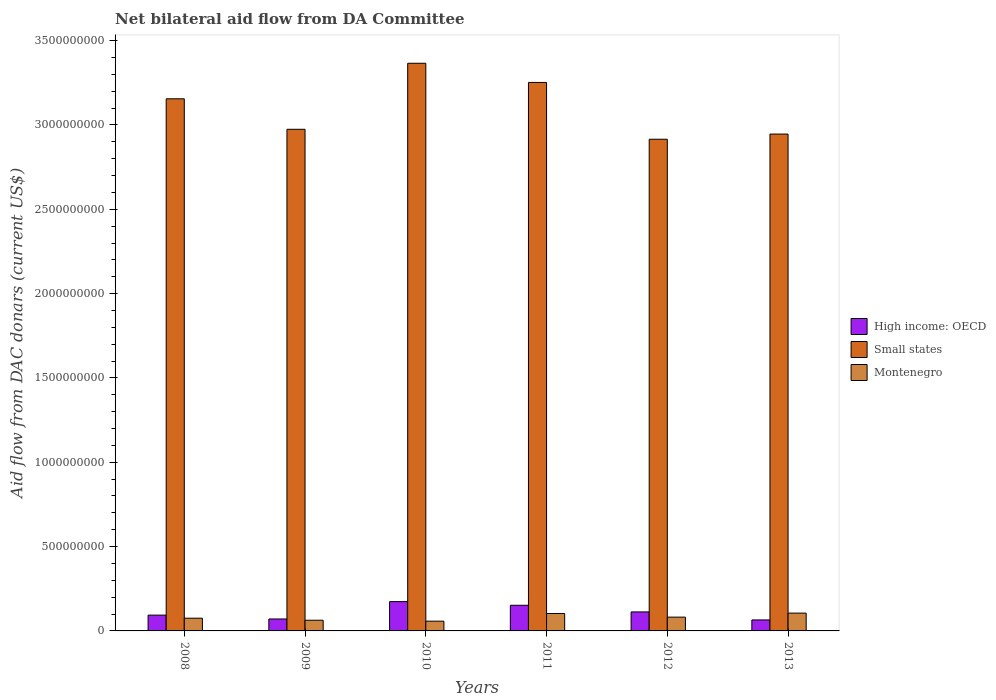How many groups of bars are there?
Give a very brief answer. 6. Are the number of bars per tick equal to the number of legend labels?
Offer a very short reply. Yes. Are the number of bars on each tick of the X-axis equal?
Keep it short and to the point. Yes. What is the label of the 6th group of bars from the left?
Provide a short and direct response. 2013. What is the aid flow in in High income: OECD in 2008?
Provide a succinct answer. 9.37e+07. Across all years, what is the maximum aid flow in in High income: OECD?
Ensure brevity in your answer.  1.74e+08. Across all years, what is the minimum aid flow in in Small states?
Your answer should be very brief. 2.92e+09. In which year was the aid flow in in Montenegro maximum?
Offer a terse response. 2013. In which year was the aid flow in in High income: OECD minimum?
Offer a terse response. 2013. What is the total aid flow in in Small states in the graph?
Your response must be concise. 1.86e+1. What is the difference between the aid flow in in High income: OECD in 2010 and that in 2013?
Give a very brief answer. 1.09e+08. What is the difference between the aid flow in in High income: OECD in 2010 and the aid flow in in Montenegro in 2012?
Offer a very short reply. 9.20e+07. What is the average aid flow in in Montenegro per year?
Your response must be concise. 8.12e+07. In the year 2012, what is the difference between the aid flow in in Small states and aid flow in in Montenegro?
Your response must be concise. 2.83e+09. What is the ratio of the aid flow in in Small states in 2009 to that in 2013?
Provide a succinct answer. 1.01. Is the aid flow in in Small states in 2012 less than that in 2013?
Your answer should be compact. Yes. What is the difference between the highest and the second highest aid flow in in Montenegro?
Offer a very short reply. 2.31e+06. What is the difference between the highest and the lowest aid flow in in Montenegro?
Ensure brevity in your answer.  4.77e+07. In how many years, is the aid flow in in Montenegro greater than the average aid flow in in Montenegro taken over all years?
Your response must be concise. 3. Is the sum of the aid flow in in Small states in 2009 and 2010 greater than the maximum aid flow in in High income: OECD across all years?
Give a very brief answer. Yes. What does the 1st bar from the left in 2009 represents?
Give a very brief answer. High income: OECD. What does the 1st bar from the right in 2012 represents?
Ensure brevity in your answer.  Montenegro. Is it the case that in every year, the sum of the aid flow in in Montenegro and aid flow in in High income: OECD is greater than the aid flow in in Small states?
Make the answer very short. No. Are all the bars in the graph horizontal?
Offer a terse response. No. Are the values on the major ticks of Y-axis written in scientific E-notation?
Make the answer very short. No. Does the graph contain any zero values?
Offer a very short reply. No. How many legend labels are there?
Ensure brevity in your answer.  3. What is the title of the graph?
Offer a very short reply. Net bilateral aid flow from DA Committee. What is the label or title of the X-axis?
Offer a terse response. Years. What is the label or title of the Y-axis?
Offer a terse response. Aid flow from DAC donars (current US$). What is the Aid flow from DAC donars (current US$) of High income: OECD in 2008?
Your response must be concise. 9.37e+07. What is the Aid flow from DAC donars (current US$) of Small states in 2008?
Make the answer very short. 3.16e+09. What is the Aid flow from DAC donars (current US$) of Montenegro in 2008?
Provide a short and direct response. 7.55e+07. What is the Aid flow from DAC donars (current US$) of High income: OECD in 2009?
Provide a short and direct response. 7.08e+07. What is the Aid flow from DAC donars (current US$) in Small states in 2009?
Offer a terse response. 2.97e+09. What is the Aid flow from DAC donars (current US$) in Montenegro in 2009?
Give a very brief answer. 6.33e+07. What is the Aid flow from DAC donars (current US$) of High income: OECD in 2010?
Your answer should be compact. 1.74e+08. What is the Aid flow from DAC donars (current US$) of Small states in 2010?
Make the answer very short. 3.37e+09. What is the Aid flow from DAC donars (current US$) in Montenegro in 2010?
Your answer should be very brief. 5.79e+07. What is the Aid flow from DAC donars (current US$) of High income: OECD in 2011?
Ensure brevity in your answer.  1.52e+08. What is the Aid flow from DAC donars (current US$) in Small states in 2011?
Offer a terse response. 3.25e+09. What is the Aid flow from DAC donars (current US$) in Montenegro in 2011?
Ensure brevity in your answer.  1.03e+08. What is the Aid flow from DAC donars (current US$) of High income: OECD in 2012?
Your answer should be compact. 1.13e+08. What is the Aid flow from DAC donars (current US$) of Small states in 2012?
Your response must be concise. 2.92e+09. What is the Aid flow from DAC donars (current US$) of Montenegro in 2012?
Provide a succinct answer. 8.17e+07. What is the Aid flow from DAC donars (current US$) of High income: OECD in 2013?
Offer a terse response. 6.52e+07. What is the Aid flow from DAC donars (current US$) of Small states in 2013?
Your answer should be compact. 2.95e+09. What is the Aid flow from DAC donars (current US$) in Montenegro in 2013?
Your answer should be very brief. 1.06e+08. Across all years, what is the maximum Aid flow from DAC donars (current US$) in High income: OECD?
Provide a short and direct response. 1.74e+08. Across all years, what is the maximum Aid flow from DAC donars (current US$) in Small states?
Provide a short and direct response. 3.37e+09. Across all years, what is the maximum Aid flow from DAC donars (current US$) of Montenegro?
Provide a short and direct response. 1.06e+08. Across all years, what is the minimum Aid flow from DAC donars (current US$) of High income: OECD?
Provide a succinct answer. 6.52e+07. Across all years, what is the minimum Aid flow from DAC donars (current US$) in Small states?
Your answer should be very brief. 2.92e+09. Across all years, what is the minimum Aid flow from DAC donars (current US$) of Montenegro?
Your response must be concise. 5.79e+07. What is the total Aid flow from DAC donars (current US$) of High income: OECD in the graph?
Make the answer very short. 6.68e+08. What is the total Aid flow from DAC donars (current US$) of Small states in the graph?
Provide a succinct answer. 1.86e+1. What is the total Aid flow from DAC donars (current US$) of Montenegro in the graph?
Offer a terse response. 4.87e+08. What is the difference between the Aid flow from DAC donars (current US$) of High income: OECD in 2008 and that in 2009?
Make the answer very short. 2.29e+07. What is the difference between the Aid flow from DAC donars (current US$) in Small states in 2008 and that in 2009?
Offer a terse response. 1.81e+08. What is the difference between the Aid flow from DAC donars (current US$) of Montenegro in 2008 and that in 2009?
Provide a succinct answer. 1.22e+07. What is the difference between the Aid flow from DAC donars (current US$) in High income: OECD in 2008 and that in 2010?
Your response must be concise. -8.01e+07. What is the difference between the Aid flow from DAC donars (current US$) of Small states in 2008 and that in 2010?
Your answer should be very brief. -2.11e+08. What is the difference between the Aid flow from DAC donars (current US$) of Montenegro in 2008 and that in 2010?
Make the answer very short. 1.76e+07. What is the difference between the Aid flow from DAC donars (current US$) in High income: OECD in 2008 and that in 2011?
Make the answer very short. -5.84e+07. What is the difference between the Aid flow from DAC donars (current US$) in Small states in 2008 and that in 2011?
Provide a succinct answer. -9.70e+07. What is the difference between the Aid flow from DAC donars (current US$) in Montenegro in 2008 and that in 2011?
Your answer should be compact. -2.78e+07. What is the difference between the Aid flow from DAC donars (current US$) in High income: OECD in 2008 and that in 2012?
Give a very brief answer. -1.90e+07. What is the difference between the Aid flow from DAC donars (current US$) of Small states in 2008 and that in 2012?
Offer a very short reply. 2.40e+08. What is the difference between the Aid flow from DAC donars (current US$) of Montenegro in 2008 and that in 2012?
Make the answer very short. -6.24e+06. What is the difference between the Aid flow from DAC donars (current US$) in High income: OECD in 2008 and that in 2013?
Offer a very short reply. 2.85e+07. What is the difference between the Aid flow from DAC donars (current US$) in Small states in 2008 and that in 2013?
Give a very brief answer. 2.09e+08. What is the difference between the Aid flow from DAC donars (current US$) in Montenegro in 2008 and that in 2013?
Your answer should be compact. -3.01e+07. What is the difference between the Aid flow from DAC donars (current US$) in High income: OECD in 2009 and that in 2010?
Keep it short and to the point. -1.03e+08. What is the difference between the Aid flow from DAC donars (current US$) of Small states in 2009 and that in 2010?
Make the answer very short. -3.91e+08. What is the difference between the Aid flow from DAC donars (current US$) in Montenegro in 2009 and that in 2010?
Ensure brevity in your answer.  5.44e+06. What is the difference between the Aid flow from DAC donars (current US$) of High income: OECD in 2009 and that in 2011?
Ensure brevity in your answer.  -8.13e+07. What is the difference between the Aid flow from DAC donars (current US$) in Small states in 2009 and that in 2011?
Your response must be concise. -2.78e+08. What is the difference between the Aid flow from DAC donars (current US$) in Montenegro in 2009 and that in 2011?
Your answer should be compact. -4.00e+07. What is the difference between the Aid flow from DAC donars (current US$) in High income: OECD in 2009 and that in 2012?
Your answer should be very brief. -4.19e+07. What is the difference between the Aid flow from DAC donars (current US$) in Small states in 2009 and that in 2012?
Ensure brevity in your answer.  5.91e+07. What is the difference between the Aid flow from DAC donars (current US$) in Montenegro in 2009 and that in 2012?
Offer a terse response. -1.84e+07. What is the difference between the Aid flow from DAC donars (current US$) of High income: OECD in 2009 and that in 2013?
Offer a terse response. 5.59e+06. What is the difference between the Aid flow from DAC donars (current US$) of Small states in 2009 and that in 2013?
Your response must be concise. 2.84e+07. What is the difference between the Aid flow from DAC donars (current US$) in Montenegro in 2009 and that in 2013?
Offer a very short reply. -4.23e+07. What is the difference between the Aid flow from DAC donars (current US$) in High income: OECD in 2010 and that in 2011?
Give a very brief answer. 2.17e+07. What is the difference between the Aid flow from DAC donars (current US$) of Small states in 2010 and that in 2011?
Your response must be concise. 1.14e+08. What is the difference between the Aid flow from DAC donars (current US$) in Montenegro in 2010 and that in 2011?
Your answer should be compact. -4.54e+07. What is the difference between the Aid flow from DAC donars (current US$) in High income: OECD in 2010 and that in 2012?
Your response must be concise. 6.11e+07. What is the difference between the Aid flow from DAC donars (current US$) of Small states in 2010 and that in 2012?
Provide a short and direct response. 4.51e+08. What is the difference between the Aid flow from DAC donars (current US$) in Montenegro in 2010 and that in 2012?
Offer a terse response. -2.39e+07. What is the difference between the Aid flow from DAC donars (current US$) of High income: OECD in 2010 and that in 2013?
Offer a very short reply. 1.09e+08. What is the difference between the Aid flow from DAC donars (current US$) of Small states in 2010 and that in 2013?
Provide a short and direct response. 4.20e+08. What is the difference between the Aid flow from DAC donars (current US$) of Montenegro in 2010 and that in 2013?
Offer a terse response. -4.77e+07. What is the difference between the Aid flow from DAC donars (current US$) of High income: OECD in 2011 and that in 2012?
Offer a terse response. 3.94e+07. What is the difference between the Aid flow from DAC donars (current US$) in Small states in 2011 and that in 2012?
Give a very brief answer. 3.37e+08. What is the difference between the Aid flow from DAC donars (current US$) in Montenegro in 2011 and that in 2012?
Keep it short and to the point. 2.16e+07. What is the difference between the Aid flow from DAC donars (current US$) in High income: OECD in 2011 and that in 2013?
Give a very brief answer. 8.68e+07. What is the difference between the Aid flow from DAC donars (current US$) in Small states in 2011 and that in 2013?
Ensure brevity in your answer.  3.06e+08. What is the difference between the Aid flow from DAC donars (current US$) in Montenegro in 2011 and that in 2013?
Give a very brief answer. -2.31e+06. What is the difference between the Aid flow from DAC donars (current US$) of High income: OECD in 2012 and that in 2013?
Give a very brief answer. 4.75e+07. What is the difference between the Aid flow from DAC donars (current US$) in Small states in 2012 and that in 2013?
Your answer should be very brief. -3.07e+07. What is the difference between the Aid flow from DAC donars (current US$) in Montenegro in 2012 and that in 2013?
Make the answer very short. -2.39e+07. What is the difference between the Aid flow from DAC donars (current US$) of High income: OECD in 2008 and the Aid flow from DAC donars (current US$) of Small states in 2009?
Your answer should be compact. -2.88e+09. What is the difference between the Aid flow from DAC donars (current US$) of High income: OECD in 2008 and the Aid flow from DAC donars (current US$) of Montenegro in 2009?
Provide a succinct answer. 3.04e+07. What is the difference between the Aid flow from DAC donars (current US$) in Small states in 2008 and the Aid flow from DAC donars (current US$) in Montenegro in 2009?
Provide a succinct answer. 3.09e+09. What is the difference between the Aid flow from DAC donars (current US$) in High income: OECD in 2008 and the Aid flow from DAC donars (current US$) in Small states in 2010?
Your answer should be very brief. -3.27e+09. What is the difference between the Aid flow from DAC donars (current US$) of High income: OECD in 2008 and the Aid flow from DAC donars (current US$) of Montenegro in 2010?
Offer a terse response. 3.58e+07. What is the difference between the Aid flow from DAC donars (current US$) of Small states in 2008 and the Aid flow from DAC donars (current US$) of Montenegro in 2010?
Your answer should be very brief. 3.10e+09. What is the difference between the Aid flow from DAC donars (current US$) in High income: OECD in 2008 and the Aid flow from DAC donars (current US$) in Small states in 2011?
Give a very brief answer. -3.16e+09. What is the difference between the Aid flow from DAC donars (current US$) of High income: OECD in 2008 and the Aid flow from DAC donars (current US$) of Montenegro in 2011?
Offer a terse response. -9.62e+06. What is the difference between the Aid flow from DAC donars (current US$) of Small states in 2008 and the Aid flow from DAC donars (current US$) of Montenegro in 2011?
Make the answer very short. 3.05e+09. What is the difference between the Aid flow from DAC donars (current US$) of High income: OECD in 2008 and the Aid flow from DAC donars (current US$) of Small states in 2012?
Offer a terse response. -2.82e+09. What is the difference between the Aid flow from DAC donars (current US$) in High income: OECD in 2008 and the Aid flow from DAC donars (current US$) in Montenegro in 2012?
Make the answer very short. 1.20e+07. What is the difference between the Aid flow from DAC donars (current US$) of Small states in 2008 and the Aid flow from DAC donars (current US$) of Montenegro in 2012?
Keep it short and to the point. 3.07e+09. What is the difference between the Aid flow from DAC donars (current US$) of High income: OECD in 2008 and the Aid flow from DAC donars (current US$) of Small states in 2013?
Ensure brevity in your answer.  -2.85e+09. What is the difference between the Aid flow from DAC donars (current US$) in High income: OECD in 2008 and the Aid flow from DAC donars (current US$) in Montenegro in 2013?
Give a very brief answer. -1.19e+07. What is the difference between the Aid flow from DAC donars (current US$) of Small states in 2008 and the Aid flow from DAC donars (current US$) of Montenegro in 2013?
Give a very brief answer. 3.05e+09. What is the difference between the Aid flow from DAC donars (current US$) in High income: OECD in 2009 and the Aid flow from DAC donars (current US$) in Small states in 2010?
Give a very brief answer. -3.30e+09. What is the difference between the Aid flow from DAC donars (current US$) in High income: OECD in 2009 and the Aid flow from DAC donars (current US$) in Montenegro in 2010?
Provide a succinct answer. 1.29e+07. What is the difference between the Aid flow from DAC donars (current US$) of Small states in 2009 and the Aid flow from DAC donars (current US$) of Montenegro in 2010?
Offer a terse response. 2.92e+09. What is the difference between the Aid flow from DAC donars (current US$) in High income: OECD in 2009 and the Aid flow from DAC donars (current US$) in Small states in 2011?
Offer a terse response. -3.18e+09. What is the difference between the Aid flow from DAC donars (current US$) in High income: OECD in 2009 and the Aid flow from DAC donars (current US$) in Montenegro in 2011?
Your response must be concise. -3.25e+07. What is the difference between the Aid flow from DAC donars (current US$) in Small states in 2009 and the Aid flow from DAC donars (current US$) in Montenegro in 2011?
Provide a short and direct response. 2.87e+09. What is the difference between the Aid flow from DAC donars (current US$) in High income: OECD in 2009 and the Aid flow from DAC donars (current US$) in Small states in 2012?
Make the answer very short. -2.84e+09. What is the difference between the Aid flow from DAC donars (current US$) in High income: OECD in 2009 and the Aid flow from DAC donars (current US$) in Montenegro in 2012?
Your answer should be compact. -1.09e+07. What is the difference between the Aid flow from DAC donars (current US$) of Small states in 2009 and the Aid flow from DAC donars (current US$) of Montenegro in 2012?
Make the answer very short. 2.89e+09. What is the difference between the Aid flow from DAC donars (current US$) of High income: OECD in 2009 and the Aid flow from DAC donars (current US$) of Small states in 2013?
Your answer should be compact. -2.88e+09. What is the difference between the Aid flow from DAC donars (current US$) in High income: OECD in 2009 and the Aid flow from DAC donars (current US$) in Montenegro in 2013?
Your answer should be compact. -3.48e+07. What is the difference between the Aid flow from DAC donars (current US$) of Small states in 2009 and the Aid flow from DAC donars (current US$) of Montenegro in 2013?
Provide a succinct answer. 2.87e+09. What is the difference between the Aid flow from DAC donars (current US$) of High income: OECD in 2010 and the Aid flow from DAC donars (current US$) of Small states in 2011?
Keep it short and to the point. -3.08e+09. What is the difference between the Aid flow from DAC donars (current US$) of High income: OECD in 2010 and the Aid flow from DAC donars (current US$) of Montenegro in 2011?
Offer a very short reply. 7.04e+07. What is the difference between the Aid flow from DAC donars (current US$) of Small states in 2010 and the Aid flow from DAC donars (current US$) of Montenegro in 2011?
Offer a very short reply. 3.26e+09. What is the difference between the Aid flow from DAC donars (current US$) of High income: OECD in 2010 and the Aid flow from DAC donars (current US$) of Small states in 2012?
Your response must be concise. -2.74e+09. What is the difference between the Aid flow from DAC donars (current US$) in High income: OECD in 2010 and the Aid flow from DAC donars (current US$) in Montenegro in 2012?
Your answer should be compact. 9.20e+07. What is the difference between the Aid flow from DAC donars (current US$) in Small states in 2010 and the Aid flow from DAC donars (current US$) in Montenegro in 2012?
Ensure brevity in your answer.  3.28e+09. What is the difference between the Aid flow from DAC donars (current US$) in High income: OECD in 2010 and the Aid flow from DAC donars (current US$) in Small states in 2013?
Offer a very short reply. -2.77e+09. What is the difference between the Aid flow from DAC donars (current US$) of High income: OECD in 2010 and the Aid flow from DAC donars (current US$) of Montenegro in 2013?
Provide a succinct answer. 6.81e+07. What is the difference between the Aid flow from DAC donars (current US$) of Small states in 2010 and the Aid flow from DAC donars (current US$) of Montenegro in 2013?
Your answer should be compact. 3.26e+09. What is the difference between the Aid flow from DAC donars (current US$) in High income: OECD in 2011 and the Aid flow from DAC donars (current US$) in Small states in 2012?
Provide a succinct answer. -2.76e+09. What is the difference between the Aid flow from DAC donars (current US$) in High income: OECD in 2011 and the Aid flow from DAC donars (current US$) in Montenegro in 2012?
Ensure brevity in your answer.  7.03e+07. What is the difference between the Aid flow from DAC donars (current US$) in Small states in 2011 and the Aid flow from DAC donars (current US$) in Montenegro in 2012?
Provide a short and direct response. 3.17e+09. What is the difference between the Aid flow from DAC donars (current US$) of High income: OECD in 2011 and the Aid flow from DAC donars (current US$) of Small states in 2013?
Offer a terse response. -2.79e+09. What is the difference between the Aid flow from DAC donars (current US$) in High income: OECD in 2011 and the Aid flow from DAC donars (current US$) in Montenegro in 2013?
Ensure brevity in your answer.  4.64e+07. What is the difference between the Aid flow from DAC donars (current US$) of Small states in 2011 and the Aid flow from DAC donars (current US$) of Montenegro in 2013?
Offer a very short reply. 3.15e+09. What is the difference between the Aid flow from DAC donars (current US$) of High income: OECD in 2012 and the Aid flow from DAC donars (current US$) of Small states in 2013?
Make the answer very short. -2.83e+09. What is the difference between the Aid flow from DAC donars (current US$) in High income: OECD in 2012 and the Aid flow from DAC donars (current US$) in Montenegro in 2013?
Provide a short and direct response. 7.05e+06. What is the difference between the Aid flow from DAC donars (current US$) in Small states in 2012 and the Aid flow from DAC donars (current US$) in Montenegro in 2013?
Keep it short and to the point. 2.81e+09. What is the average Aid flow from DAC donars (current US$) in High income: OECD per year?
Provide a succinct answer. 1.11e+08. What is the average Aid flow from DAC donars (current US$) of Small states per year?
Offer a terse response. 3.10e+09. What is the average Aid flow from DAC donars (current US$) in Montenegro per year?
Keep it short and to the point. 8.12e+07. In the year 2008, what is the difference between the Aid flow from DAC donars (current US$) in High income: OECD and Aid flow from DAC donars (current US$) in Small states?
Your response must be concise. -3.06e+09. In the year 2008, what is the difference between the Aid flow from DAC donars (current US$) of High income: OECD and Aid flow from DAC donars (current US$) of Montenegro?
Your response must be concise. 1.82e+07. In the year 2008, what is the difference between the Aid flow from DAC donars (current US$) of Small states and Aid flow from DAC donars (current US$) of Montenegro?
Provide a succinct answer. 3.08e+09. In the year 2009, what is the difference between the Aid flow from DAC donars (current US$) of High income: OECD and Aid flow from DAC donars (current US$) of Small states?
Give a very brief answer. -2.90e+09. In the year 2009, what is the difference between the Aid flow from DAC donars (current US$) of High income: OECD and Aid flow from DAC donars (current US$) of Montenegro?
Provide a succinct answer. 7.48e+06. In the year 2009, what is the difference between the Aid flow from DAC donars (current US$) in Small states and Aid flow from DAC donars (current US$) in Montenegro?
Make the answer very short. 2.91e+09. In the year 2010, what is the difference between the Aid flow from DAC donars (current US$) of High income: OECD and Aid flow from DAC donars (current US$) of Small states?
Your answer should be very brief. -3.19e+09. In the year 2010, what is the difference between the Aid flow from DAC donars (current US$) in High income: OECD and Aid flow from DAC donars (current US$) in Montenegro?
Your response must be concise. 1.16e+08. In the year 2010, what is the difference between the Aid flow from DAC donars (current US$) in Small states and Aid flow from DAC donars (current US$) in Montenegro?
Provide a short and direct response. 3.31e+09. In the year 2011, what is the difference between the Aid flow from DAC donars (current US$) in High income: OECD and Aid flow from DAC donars (current US$) in Small states?
Your answer should be compact. -3.10e+09. In the year 2011, what is the difference between the Aid flow from DAC donars (current US$) in High income: OECD and Aid flow from DAC donars (current US$) in Montenegro?
Your answer should be compact. 4.88e+07. In the year 2011, what is the difference between the Aid flow from DAC donars (current US$) in Small states and Aid flow from DAC donars (current US$) in Montenegro?
Ensure brevity in your answer.  3.15e+09. In the year 2012, what is the difference between the Aid flow from DAC donars (current US$) in High income: OECD and Aid flow from DAC donars (current US$) in Small states?
Provide a short and direct response. -2.80e+09. In the year 2012, what is the difference between the Aid flow from DAC donars (current US$) of High income: OECD and Aid flow from DAC donars (current US$) of Montenegro?
Provide a succinct answer. 3.09e+07. In the year 2012, what is the difference between the Aid flow from DAC donars (current US$) of Small states and Aid flow from DAC donars (current US$) of Montenegro?
Offer a very short reply. 2.83e+09. In the year 2013, what is the difference between the Aid flow from DAC donars (current US$) in High income: OECD and Aid flow from DAC donars (current US$) in Small states?
Give a very brief answer. -2.88e+09. In the year 2013, what is the difference between the Aid flow from DAC donars (current US$) in High income: OECD and Aid flow from DAC donars (current US$) in Montenegro?
Offer a terse response. -4.04e+07. In the year 2013, what is the difference between the Aid flow from DAC donars (current US$) of Small states and Aid flow from DAC donars (current US$) of Montenegro?
Provide a short and direct response. 2.84e+09. What is the ratio of the Aid flow from DAC donars (current US$) of High income: OECD in 2008 to that in 2009?
Your response must be concise. 1.32. What is the ratio of the Aid flow from DAC donars (current US$) of Small states in 2008 to that in 2009?
Your answer should be compact. 1.06. What is the ratio of the Aid flow from DAC donars (current US$) in Montenegro in 2008 to that in 2009?
Ensure brevity in your answer.  1.19. What is the ratio of the Aid flow from DAC donars (current US$) in High income: OECD in 2008 to that in 2010?
Your answer should be compact. 0.54. What is the ratio of the Aid flow from DAC donars (current US$) in Small states in 2008 to that in 2010?
Offer a terse response. 0.94. What is the ratio of the Aid flow from DAC donars (current US$) of Montenegro in 2008 to that in 2010?
Offer a terse response. 1.3. What is the ratio of the Aid flow from DAC donars (current US$) of High income: OECD in 2008 to that in 2011?
Provide a succinct answer. 0.62. What is the ratio of the Aid flow from DAC donars (current US$) of Small states in 2008 to that in 2011?
Make the answer very short. 0.97. What is the ratio of the Aid flow from DAC donars (current US$) in Montenegro in 2008 to that in 2011?
Your response must be concise. 0.73. What is the ratio of the Aid flow from DAC donars (current US$) of High income: OECD in 2008 to that in 2012?
Provide a succinct answer. 0.83. What is the ratio of the Aid flow from DAC donars (current US$) of Small states in 2008 to that in 2012?
Your response must be concise. 1.08. What is the ratio of the Aid flow from DAC donars (current US$) in Montenegro in 2008 to that in 2012?
Provide a short and direct response. 0.92. What is the ratio of the Aid flow from DAC donars (current US$) of High income: OECD in 2008 to that in 2013?
Make the answer very short. 1.44. What is the ratio of the Aid flow from DAC donars (current US$) of Small states in 2008 to that in 2013?
Your answer should be very brief. 1.07. What is the ratio of the Aid flow from DAC donars (current US$) in Montenegro in 2008 to that in 2013?
Make the answer very short. 0.71. What is the ratio of the Aid flow from DAC donars (current US$) in High income: OECD in 2009 to that in 2010?
Offer a very short reply. 0.41. What is the ratio of the Aid flow from DAC donars (current US$) in Small states in 2009 to that in 2010?
Provide a short and direct response. 0.88. What is the ratio of the Aid flow from DAC donars (current US$) of Montenegro in 2009 to that in 2010?
Ensure brevity in your answer.  1.09. What is the ratio of the Aid flow from DAC donars (current US$) of High income: OECD in 2009 to that in 2011?
Your answer should be compact. 0.47. What is the ratio of the Aid flow from DAC donars (current US$) of Small states in 2009 to that in 2011?
Give a very brief answer. 0.91. What is the ratio of the Aid flow from DAC donars (current US$) in Montenegro in 2009 to that in 2011?
Keep it short and to the point. 0.61. What is the ratio of the Aid flow from DAC donars (current US$) of High income: OECD in 2009 to that in 2012?
Give a very brief answer. 0.63. What is the ratio of the Aid flow from DAC donars (current US$) in Small states in 2009 to that in 2012?
Offer a very short reply. 1.02. What is the ratio of the Aid flow from DAC donars (current US$) in Montenegro in 2009 to that in 2012?
Ensure brevity in your answer.  0.77. What is the ratio of the Aid flow from DAC donars (current US$) in High income: OECD in 2009 to that in 2013?
Ensure brevity in your answer.  1.09. What is the ratio of the Aid flow from DAC donars (current US$) in Small states in 2009 to that in 2013?
Your answer should be very brief. 1.01. What is the ratio of the Aid flow from DAC donars (current US$) in Montenegro in 2009 to that in 2013?
Provide a succinct answer. 0.6. What is the ratio of the Aid flow from DAC donars (current US$) in High income: OECD in 2010 to that in 2011?
Your answer should be very brief. 1.14. What is the ratio of the Aid flow from DAC donars (current US$) in Small states in 2010 to that in 2011?
Keep it short and to the point. 1.03. What is the ratio of the Aid flow from DAC donars (current US$) in Montenegro in 2010 to that in 2011?
Ensure brevity in your answer.  0.56. What is the ratio of the Aid flow from DAC donars (current US$) of High income: OECD in 2010 to that in 2012?
Provide a succinct answer. 1.54. What is the ratio of the Aid flow from DAC donars (current US$) of Small states in 2010 to that in 2012?
Your response must be concise. 1.15. What is the ratio of the Aid flow from DAC donars (current US$) of Montenegro in 2010 to that in 2012?
Give a very brief answer. 0.71. What is the ratio of the Aid flow from DAC donars (current US$) of High income: OECD in 2010 to that in 2013?
Your answer should be compact. 2.66. What is the ratio of the Aid flow from DAC donars (current US$) of Small states in 2010 to that in 2013?
Provide a succinct answer. 1.14. What is the ratio of the Aid flow from DAC donars (current US$) of Montenegro in 2010 to that in 2013?
Offer a very short reply. 0.55. What is the ratio of the Aid flow from DAC donars (current US$) in High income: OECD in 2011 to that in 2012?
Provide a succinct answer. 1.35. What is the ratio of the Aid flow from DAC donars (current US$) in Small states in 2011 to that in 2012?
Offer a very short reply. 1.12. What is the ratio of the Aid flow from DAC donars (current US$) of Montenegro in 2011 to that in 2012?
Your answer should be compact. 1.26. What is the ratio of the Aid flow from DAC donars (current US$) in High income: OECD in 2011 to that in 2013?
Make the answer very short. 2.33. What is the ratio of the Aid flow from DAC donars (current US$) of Small states in 2011 to that in 2013?
Offer a very short reply. 1.1. What is the ratio of the Aid flow from DAC donars (current US$) in Montenegro in 2011 to that in 2013?
Ensure brevity in your answer.  0.98. What is the ratio of the Aid flow from DAC donars (current US$) of High income: OECD in 2012 to that in 2013?
Offer a very short reply. 1.73. What is the ratio of the Aid flow from DAC donars (current US$) of Montenegro in 2012 to that in 2013?
Offer a very short reply. 0.77. What is the difference between the highest and the second highest Aid flow from DAC donars (current US$) in High income: OECD?
Your answer should be very brief. 2.17e+07. What is the difference between the highest and the second highest Aid flow from DAC donars (current US$) in Small states?
Give a very brief answer. 1.14e+08. What is the difference between the highest and the second highest Aid flow from DAC donars (current US$) of Montenegro?
Offer a very short reply. 2.31e+06. What is the difference between the highest and the lowest Aid flow from DAC donars (current US$) of High income: OECD?
Your response must be concise. 1.09e+08. What is the difference between the highest and the lowest Aid flow from DAC donars (current US$) in Small states?
Keep it short and to the point. 4.51e+08. What is the difference between the highest and the lowest Aid flow from DAC donars (current US$) in Montenegro?
Keep it short and to the point. 4.77e+07. 